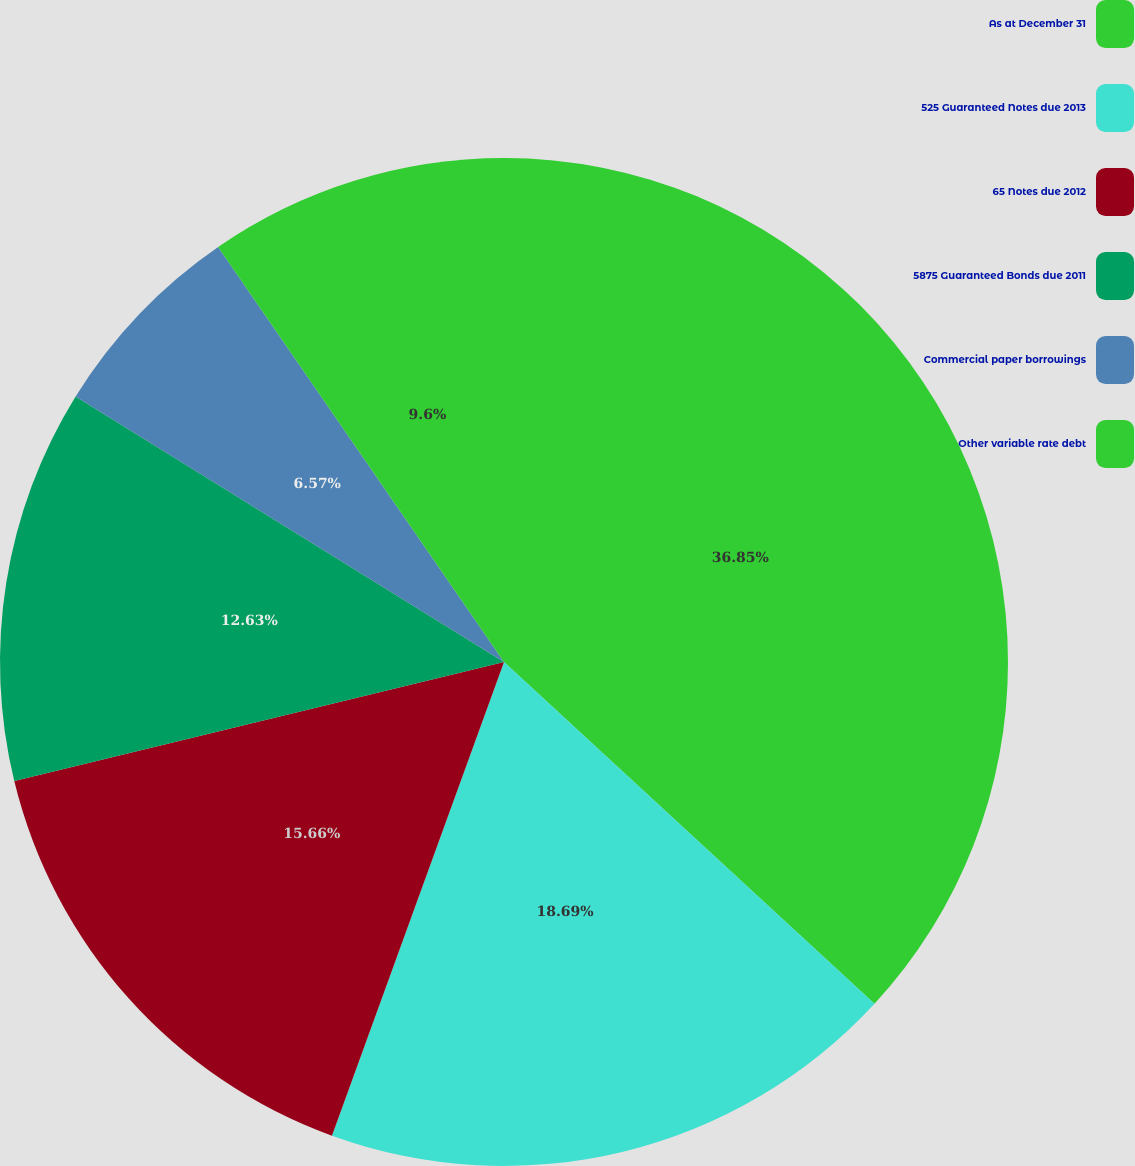Convert chart to OTSL. <chart><loc_0><loc_0><loc_500><loc_500><pie_chart><fcel>As at December 31<fcel>525 Guaranteed Notes due 2013<fcel>65 Notes due 2012<fcel>5875 Guaranteed Bonds due 2011<fcel>Commercial paper borrowings<fcel>Other variable rate debt<nl><fcel>36.86%<fcel>18.69%<fcel>15.66%<fcel>12.63%<fcel>6.57%<fcel>9.6%<nl></chart> 